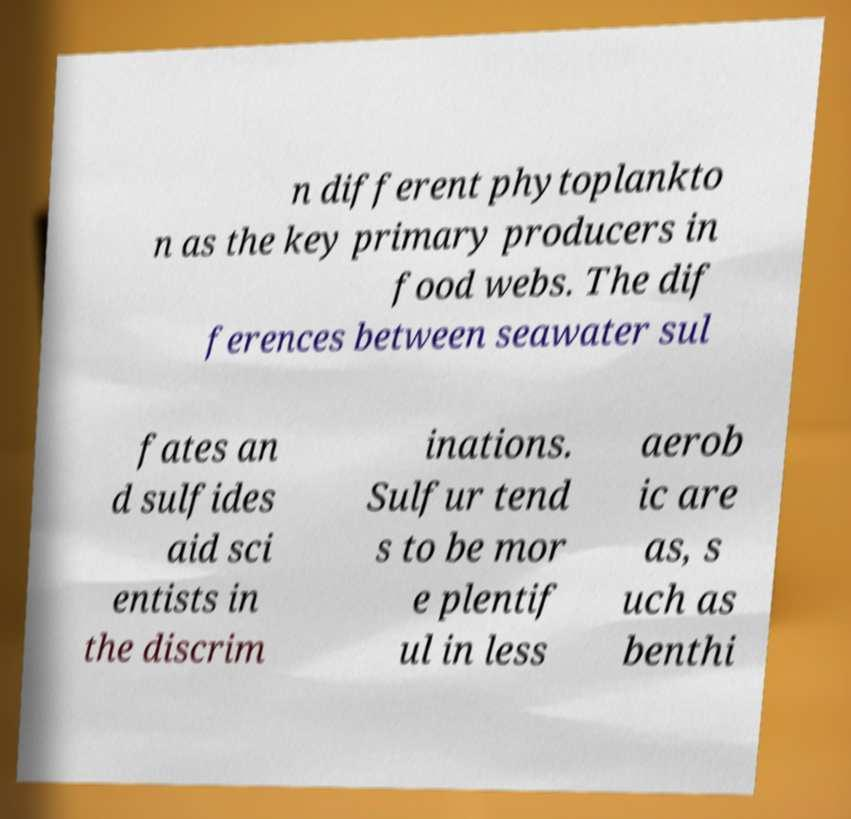Please read and relay the text visible in this image. What does it say? n different phytoplankto n as the key primary producers in food webs. The dif ferences between seawater sul fates an d sulfides aid sci entists in the discrim inations. Sulfur tend s to be mor e plentif ul in less aerob ic are as, s uch as benthi 